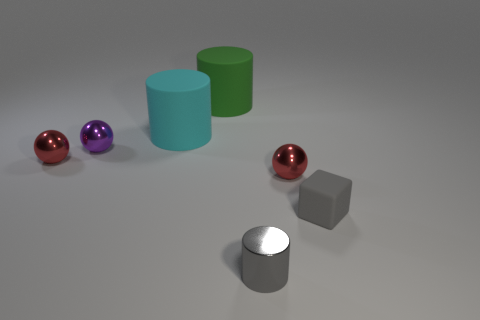How many spheres are behind the large green cylinder?
Give a very brief answer. 0. Do the gray object that is behind the shiny cylinder and the big green rubber cylinder have the same size?
Provide a succinct answer. No. There is a small metal object that is the same shape as the green matte thing; what color is it?
Keep it short and to the point. Gray. Is there any other thing that has the same shape as the purple metallic thing?
Provide a succinct answer. Yes. There is a tiny object in front of the gray cube; what shape is it?
Provide a succinct answer. Cylinder. What number of other small purple objects are the same shape as the purple metallic object?
Your answer should be compact. 0. Does the small sphere that is to the right of the large green matte cylinder have the same color as the matte thing right of the gray metallic cylinder?
Your answer should be very brief. No. What number of things are small green cubes or small gray objects?
Provide a succinct answer. 2. How many small objects have the same material as the big green cylinder?
Make the answer very short. 1. Is the number of tiny gray metallic cylinders less than the number of big gray spheres?
Ensure brevity in your answer.  No. 